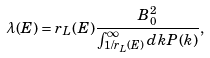<formula> <loc_0><loc_0><loc_500><loc_500>\lambda ( E ) = r _ { L } ( E ) \frac { B _ { 0 } ^ { 2 } } { \int _ { 1 / r _ { L } ( E ) } ^ { \infty } d k P ( k ) } ,</formula> 